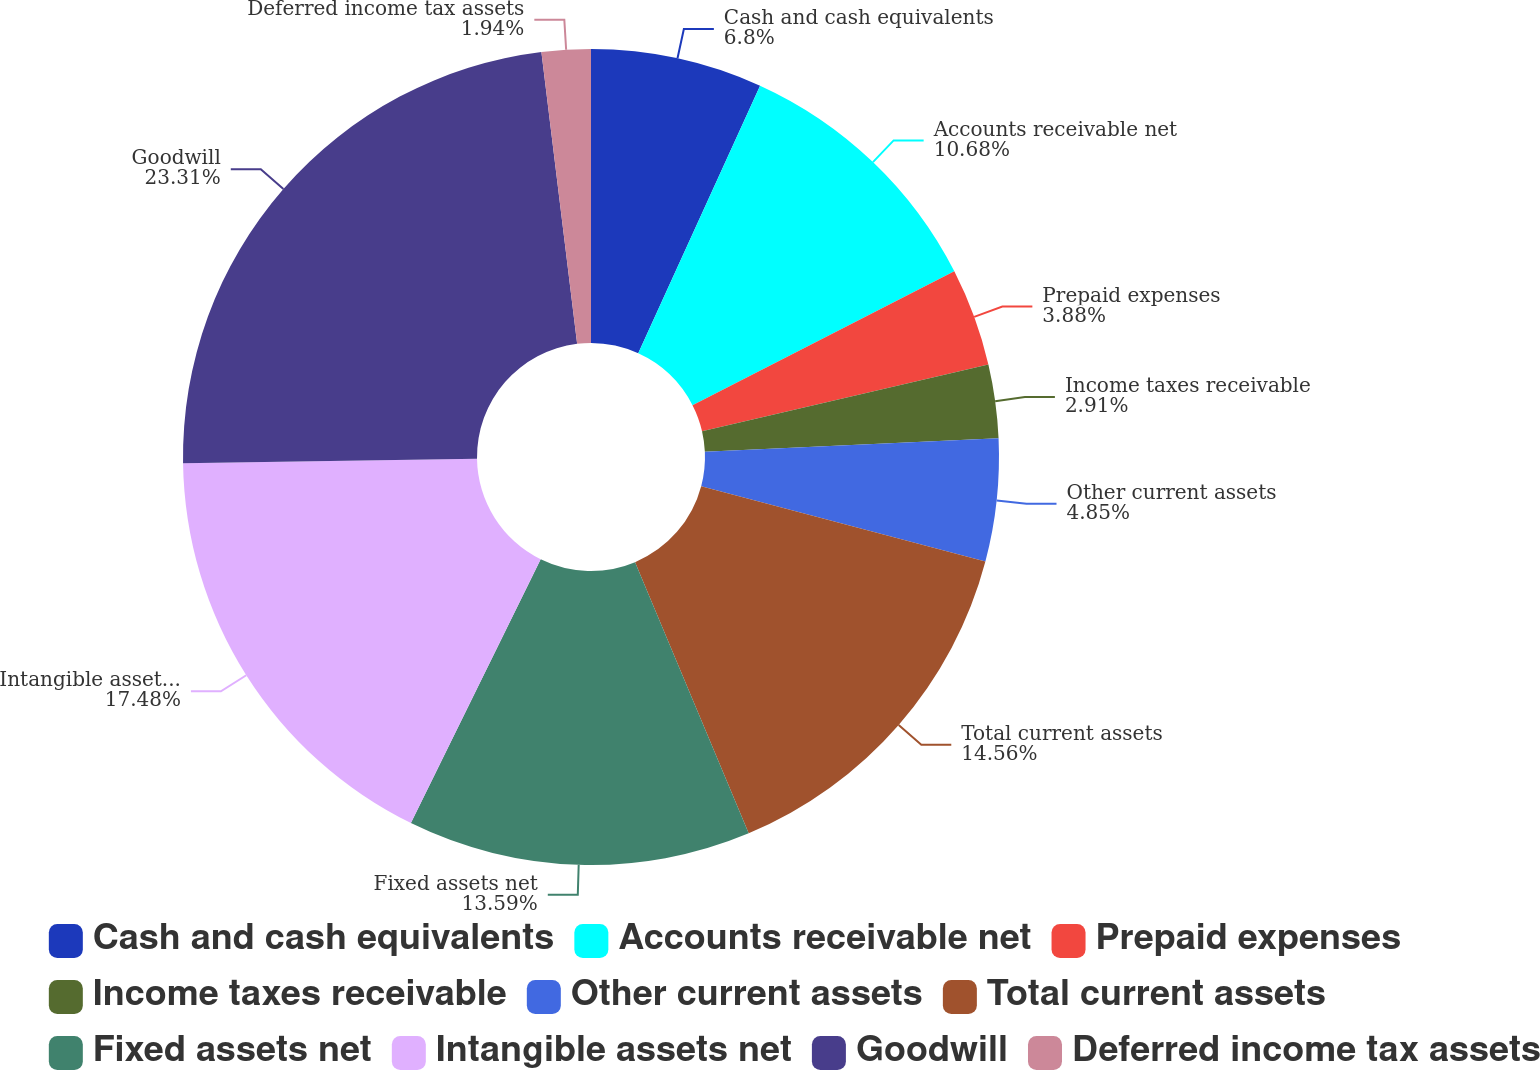<chart> <loc_0><loc_0><loc_500><loc_500><pie_chart><fcel>Cash and cash equivalents<fcel>Accounts receivable net<fcel>Prepaid expenses<fcel>Income taxes receivable<fcel>Other current assets<fcel>Total current assets<fcel>Fixed assets net<fcel>Intangible assets net<fcel>Goodwill<fcel>Deferred income tax assets<nl><fcel>6.8%<fcel>10.68%<fcel>3.88%<fcel>2.91%<fcel>4.85%<fcel>14.56%<fcel>13.59%<fcel>17.48%<fcel>23.3%<fcel>1.94%<nl></chart> 